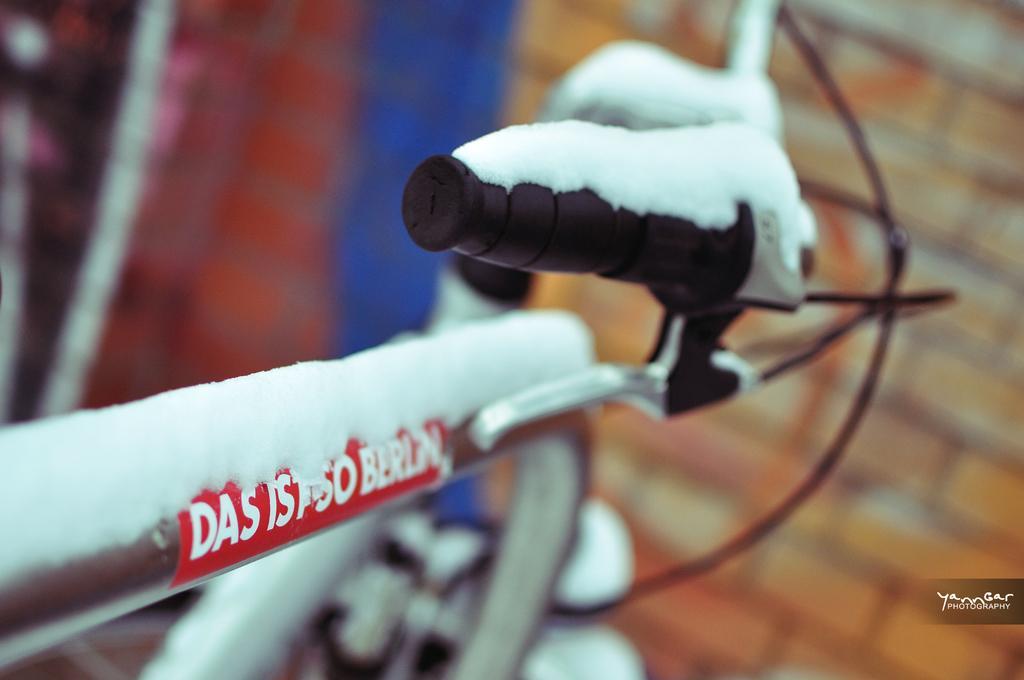Could you give a brief overview of what you see in this image? In this image, we can see a bicycle and we can see snow on the bicycle. In the background, we can see the brick wall. 